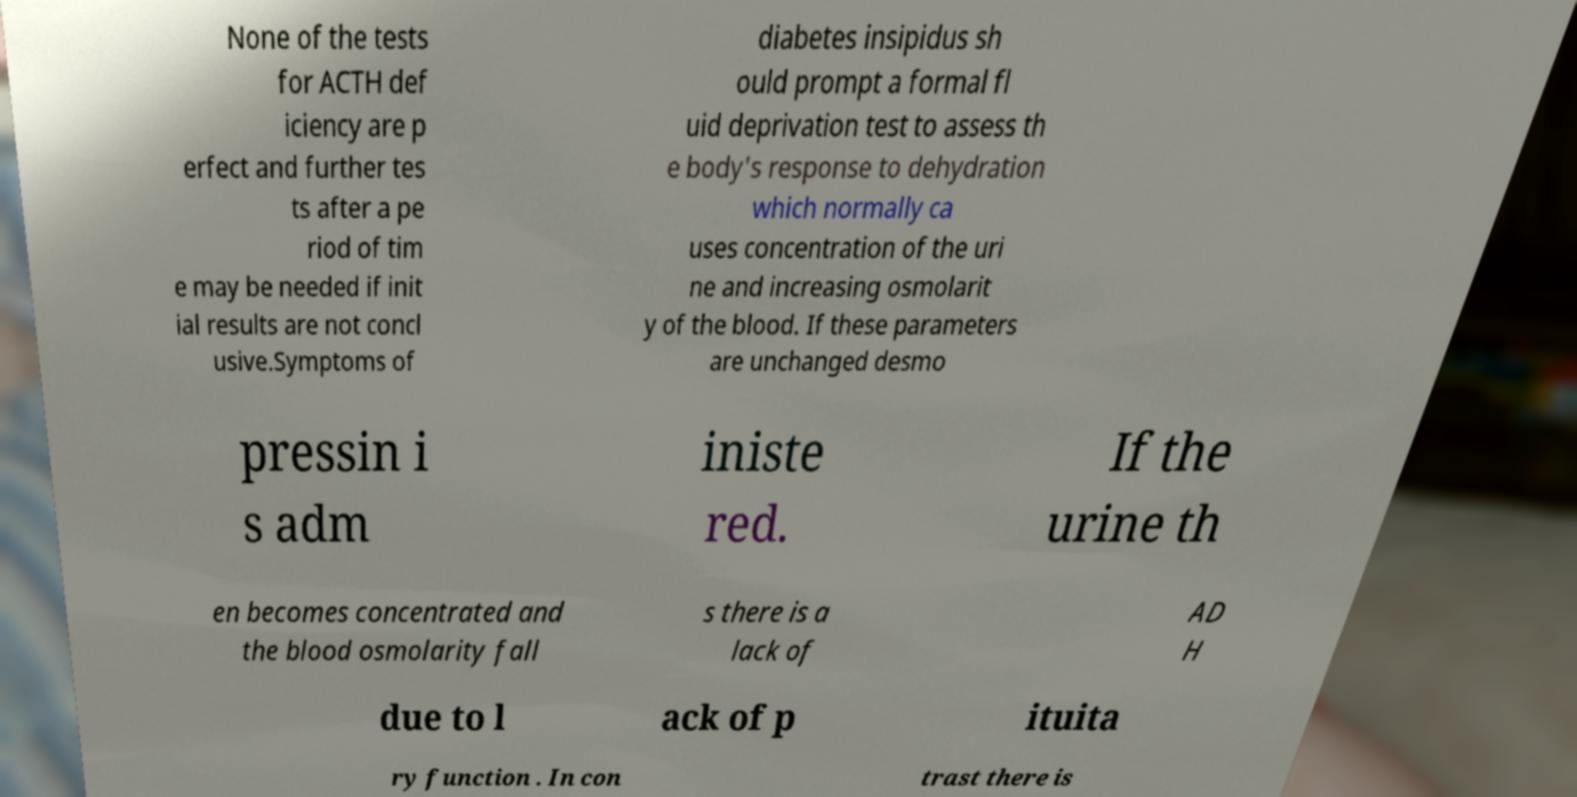For documentation purposes, I need the text within this image transcribed. Could you provide that? None of the tests for ACTH def iciency are p erfect and further tes ts after a pe riod of tim e may be needed if init ial results are not concl usive.Symptoms of diabetes insipidus sh ould prompt a formal fl uid deprivation test to assess th e body's response to dehydration which normally ca uses concentration of the uri ne and increasing osmolarit y of the blood. If these parameters are unchanged desmo pressin i s adm iniste red. If the urine th en becomes concentrated and the blood osmolarity fall s there is a lack of AD H due to l ack of p ituita ry function . In con trast there is 